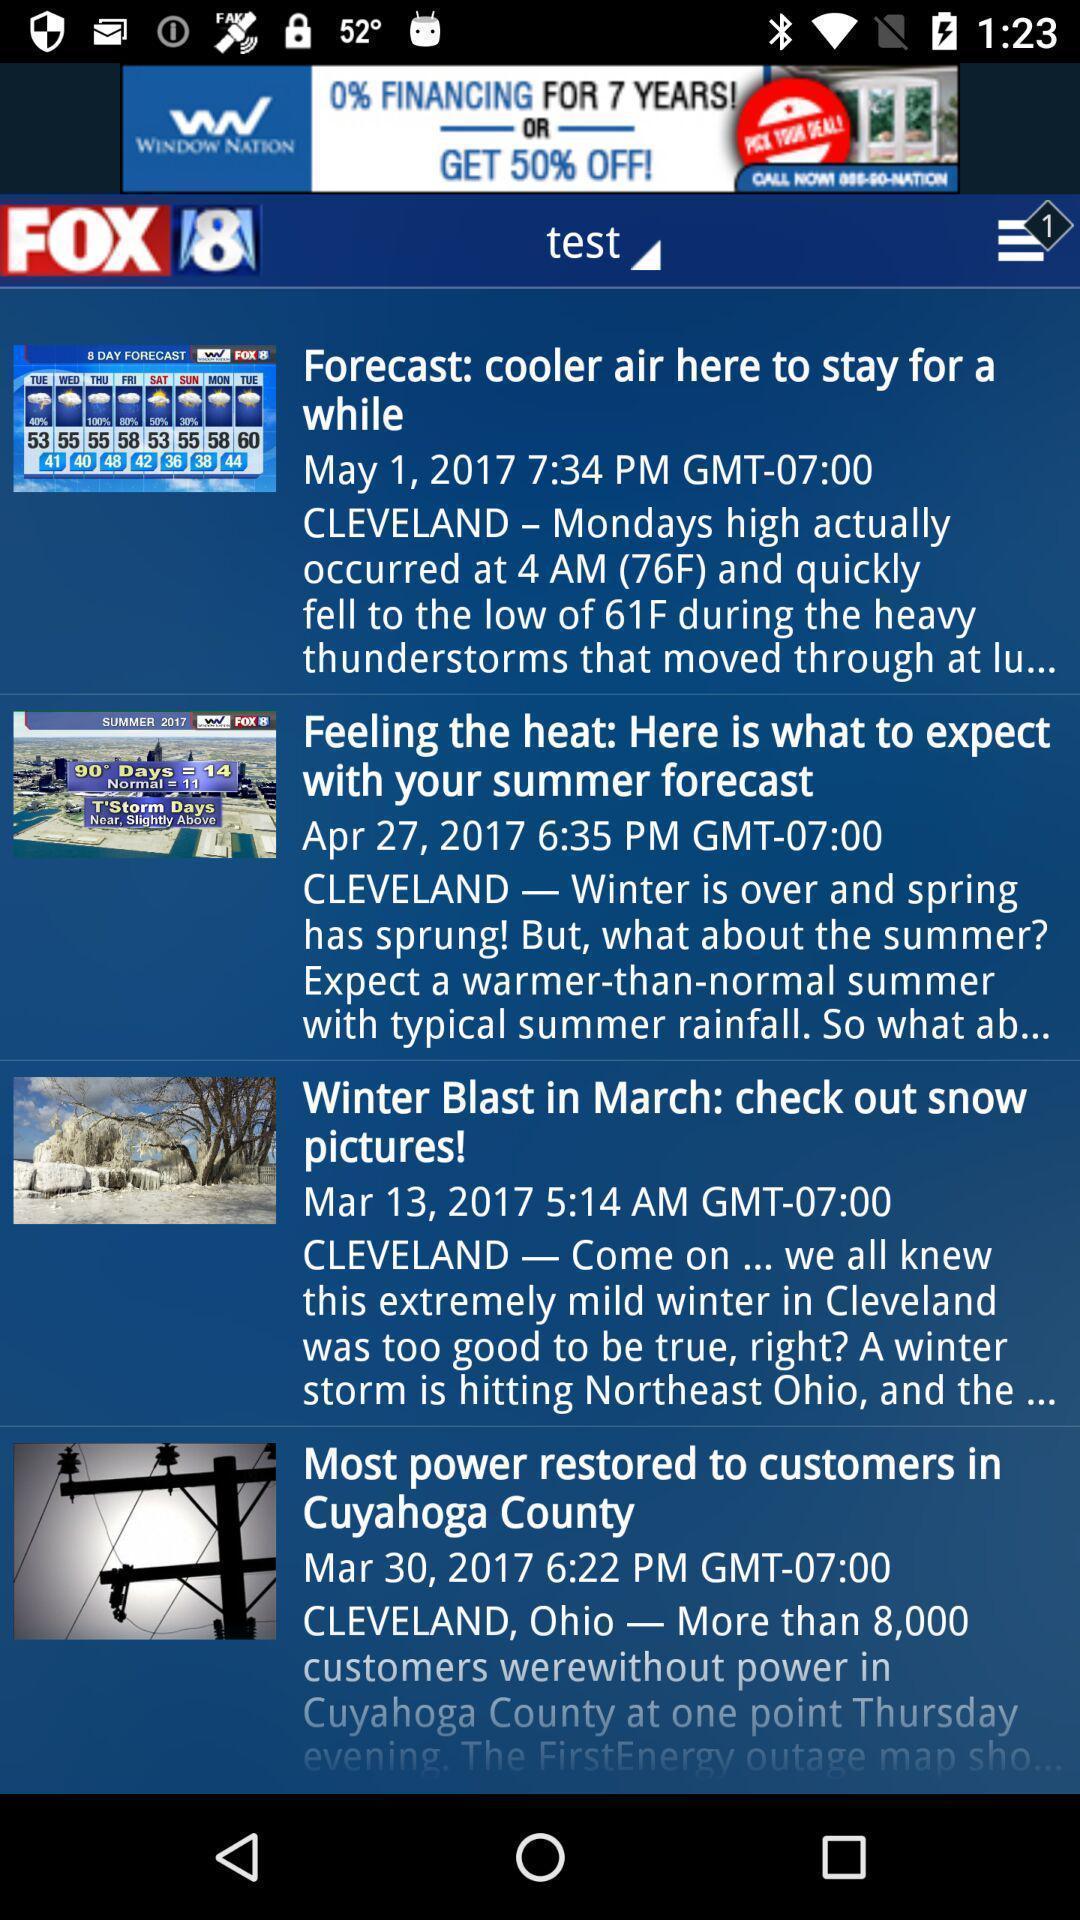Summarize the main components in this picture. Screen showing various articles on a news app. 